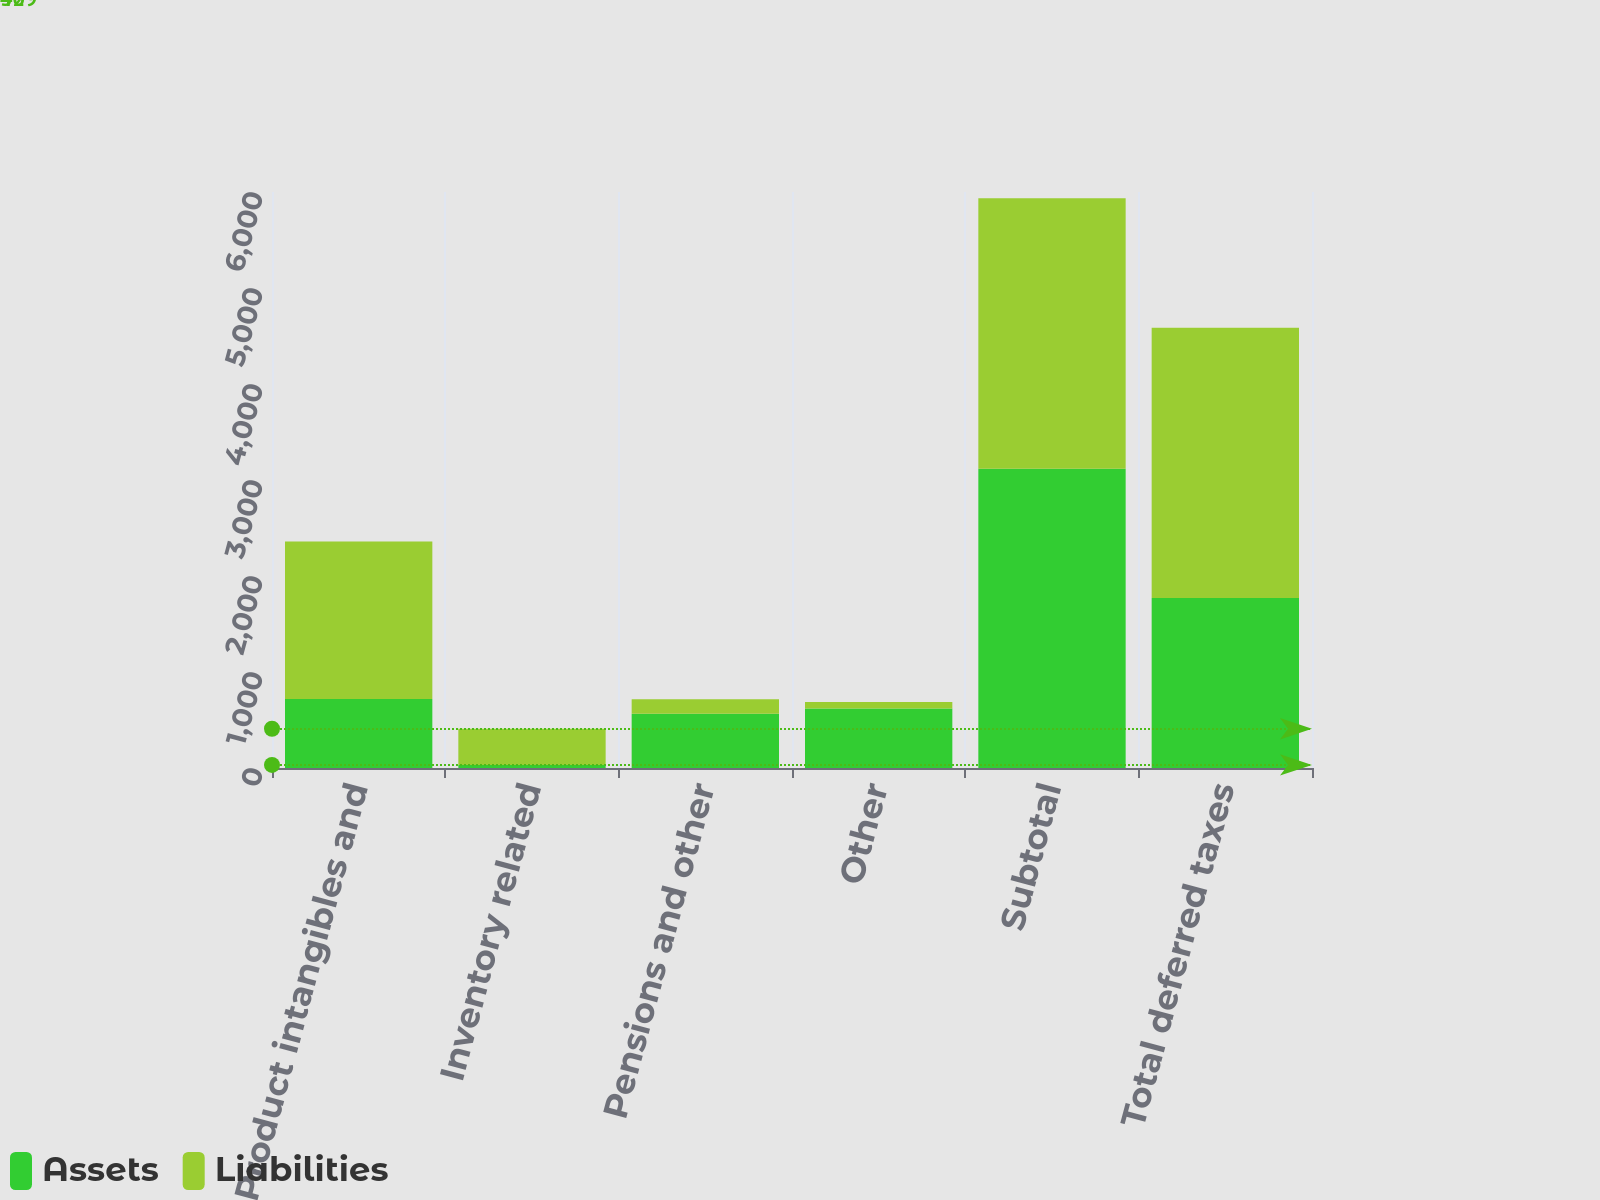<chart> <loc_0><loc_0><loc_500><loc_500><stacked_bar_chart><ecel><fcel>Product intangibles and<fcel>Inventory related<fcel>Pensions and other<fcel>Other<fcel>Subtotal<fcel>Total deferred taxes<nl><fcel>Assets<fcel>720<fcel>32<fcel>565<fcel>621<fcel>3118<fcel>1770<nl><fcel>Liabilities<fcel>1640<fcel>377<fcel>151<fcel>66<fcel>2816<fcel>2816<nl></chart> 